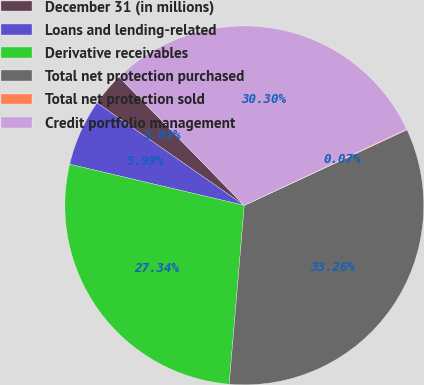<chart> <loc_0><loc_0><loc_500><loc_500><pie_chart><fcel>December 31 (in millions)<fcel>Loans and lending-related<fcel>Derivative receivables<fcel>Total net protection purchased<fcel>Total net protection sold<fcel>Credit portfolio management<nl><fcel>3.03%<fcel>5.99%<fcel>27.34%<fcel>33.26%<fcel>0.07%<fcel>30.3%<nl></chart> 